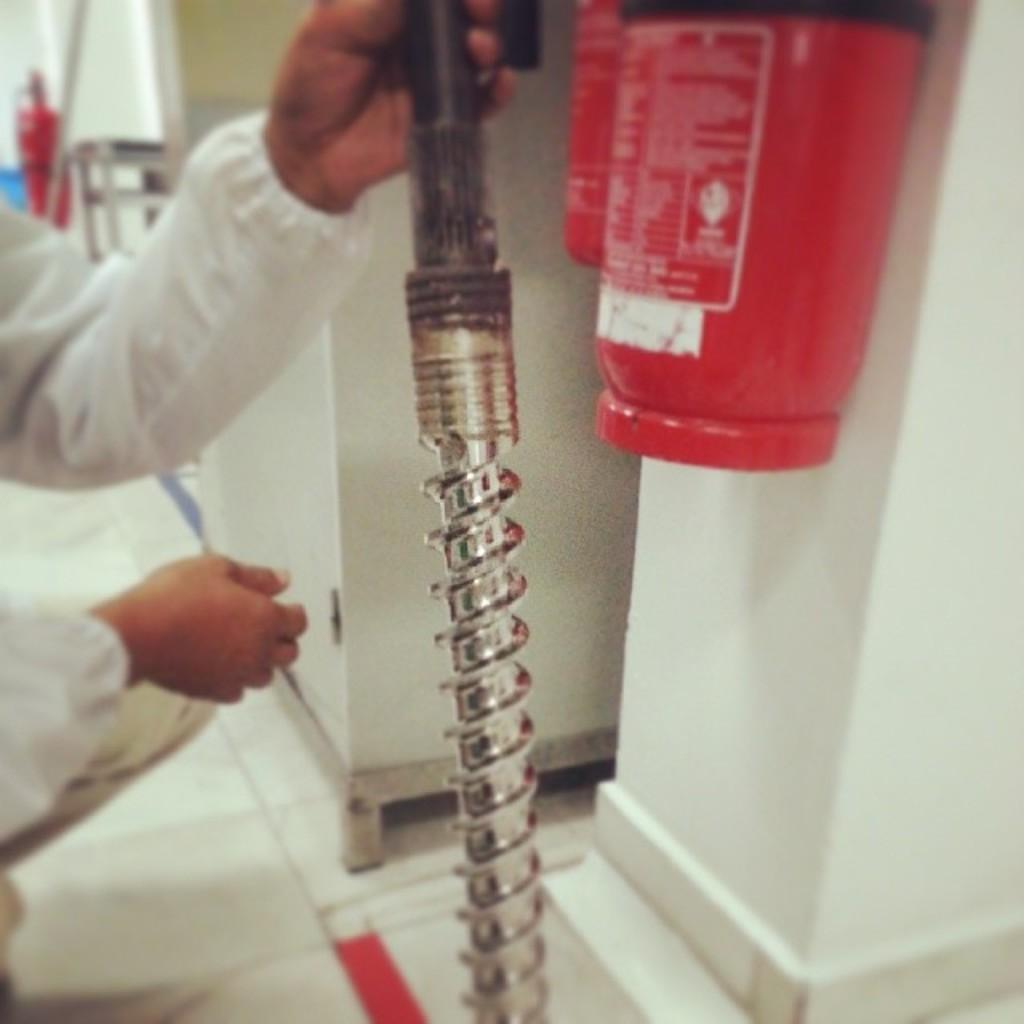What is the person in the image holding? The person is holding an iron rod in the image. What safety equipment can be seen on the wall in the image? There are two fire extinguishers on the wall in the image. What can be observed on a surface in the image? There are objects on a surface in the image. How much money does the person in the image earn per year? There is no information about the person's income in the image, so it cannot be determined. 